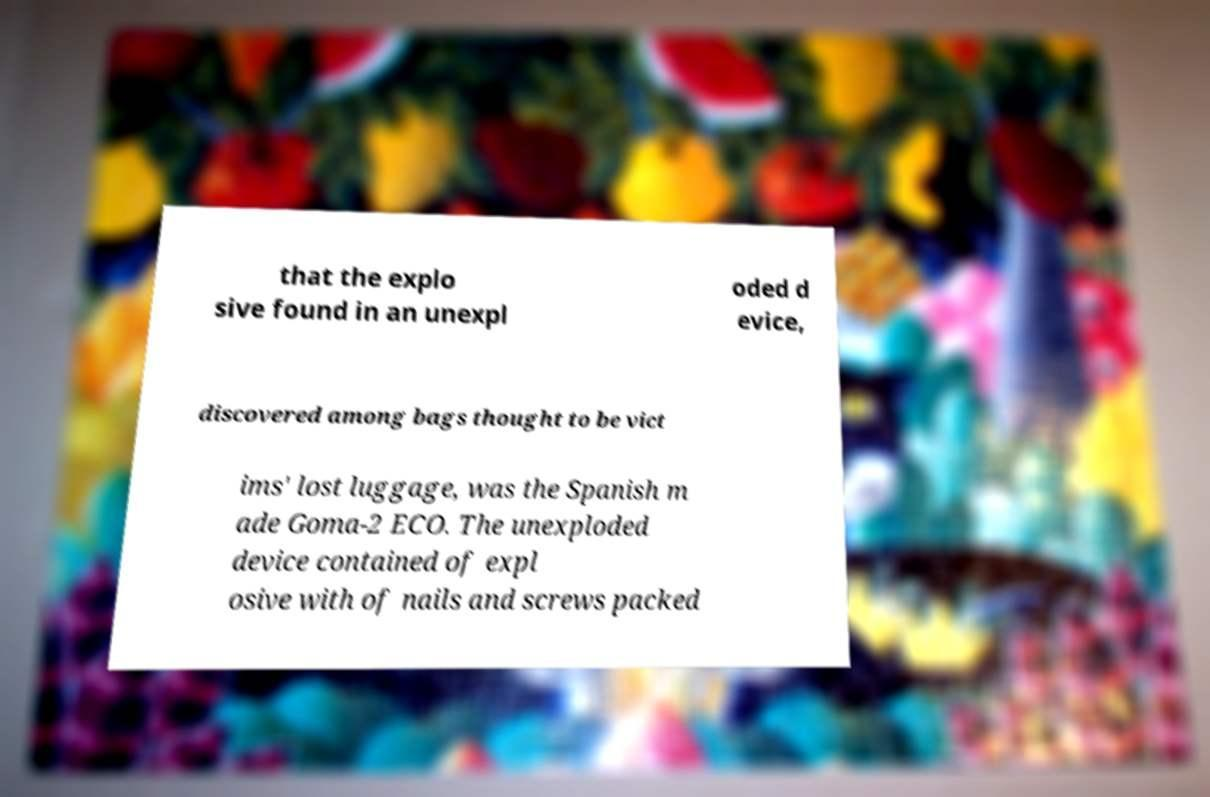For documentation purposes, I need the text within this image transcribed. Could you provide that? that the explo sive found in an unexpl oded d evice, discovered among bags thought to be vict ims' lost luggage, was the Spanish m ade Goma-2 ECO. The unexploded device contained of expl osive with of nails and screws packed 